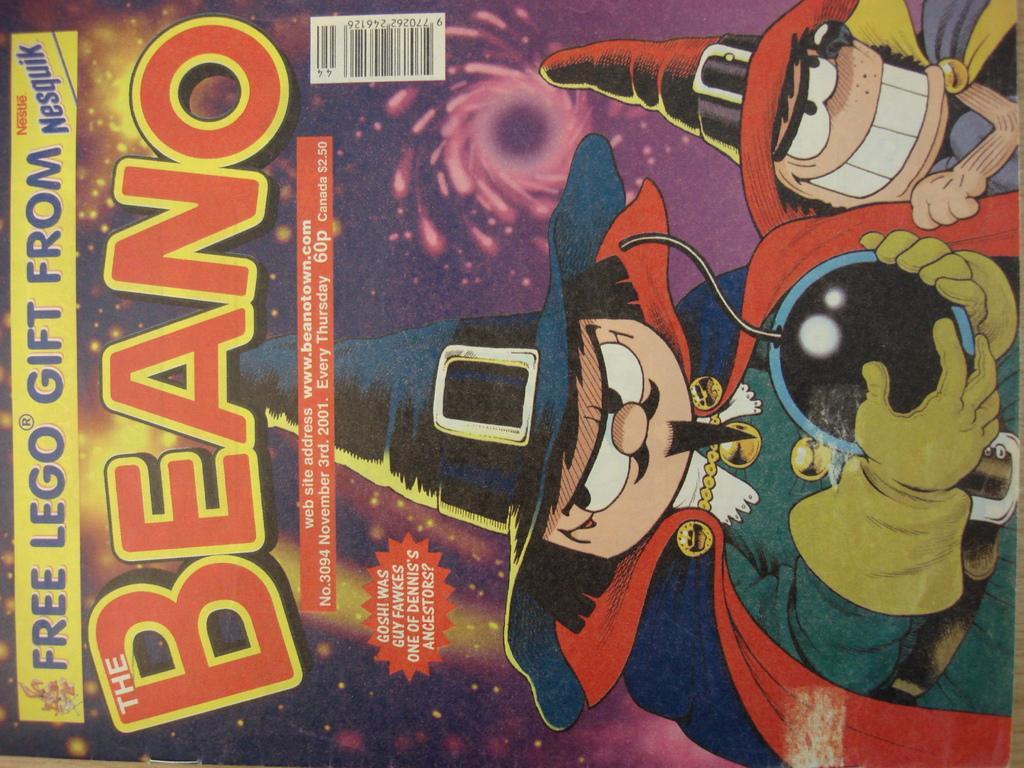Could you give a brief overview of what you see in this image? In this picture there is a poster. In that poster we can see the cartoon person who is wearing hat, gloves and green dress. He is holding bomb. In the top left we can see another cartoon person who is wearing hat and dress. In the back we can see stars and sky. On the left we can see the content name. 